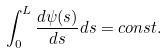Convert formula to latex. <formula><loc_0><loc_0><loc_500><loc_500>\int _ { 0 } ^ { L } \frac { d \psi ( s ) } { d s } d s = c o n s t .</formula> 